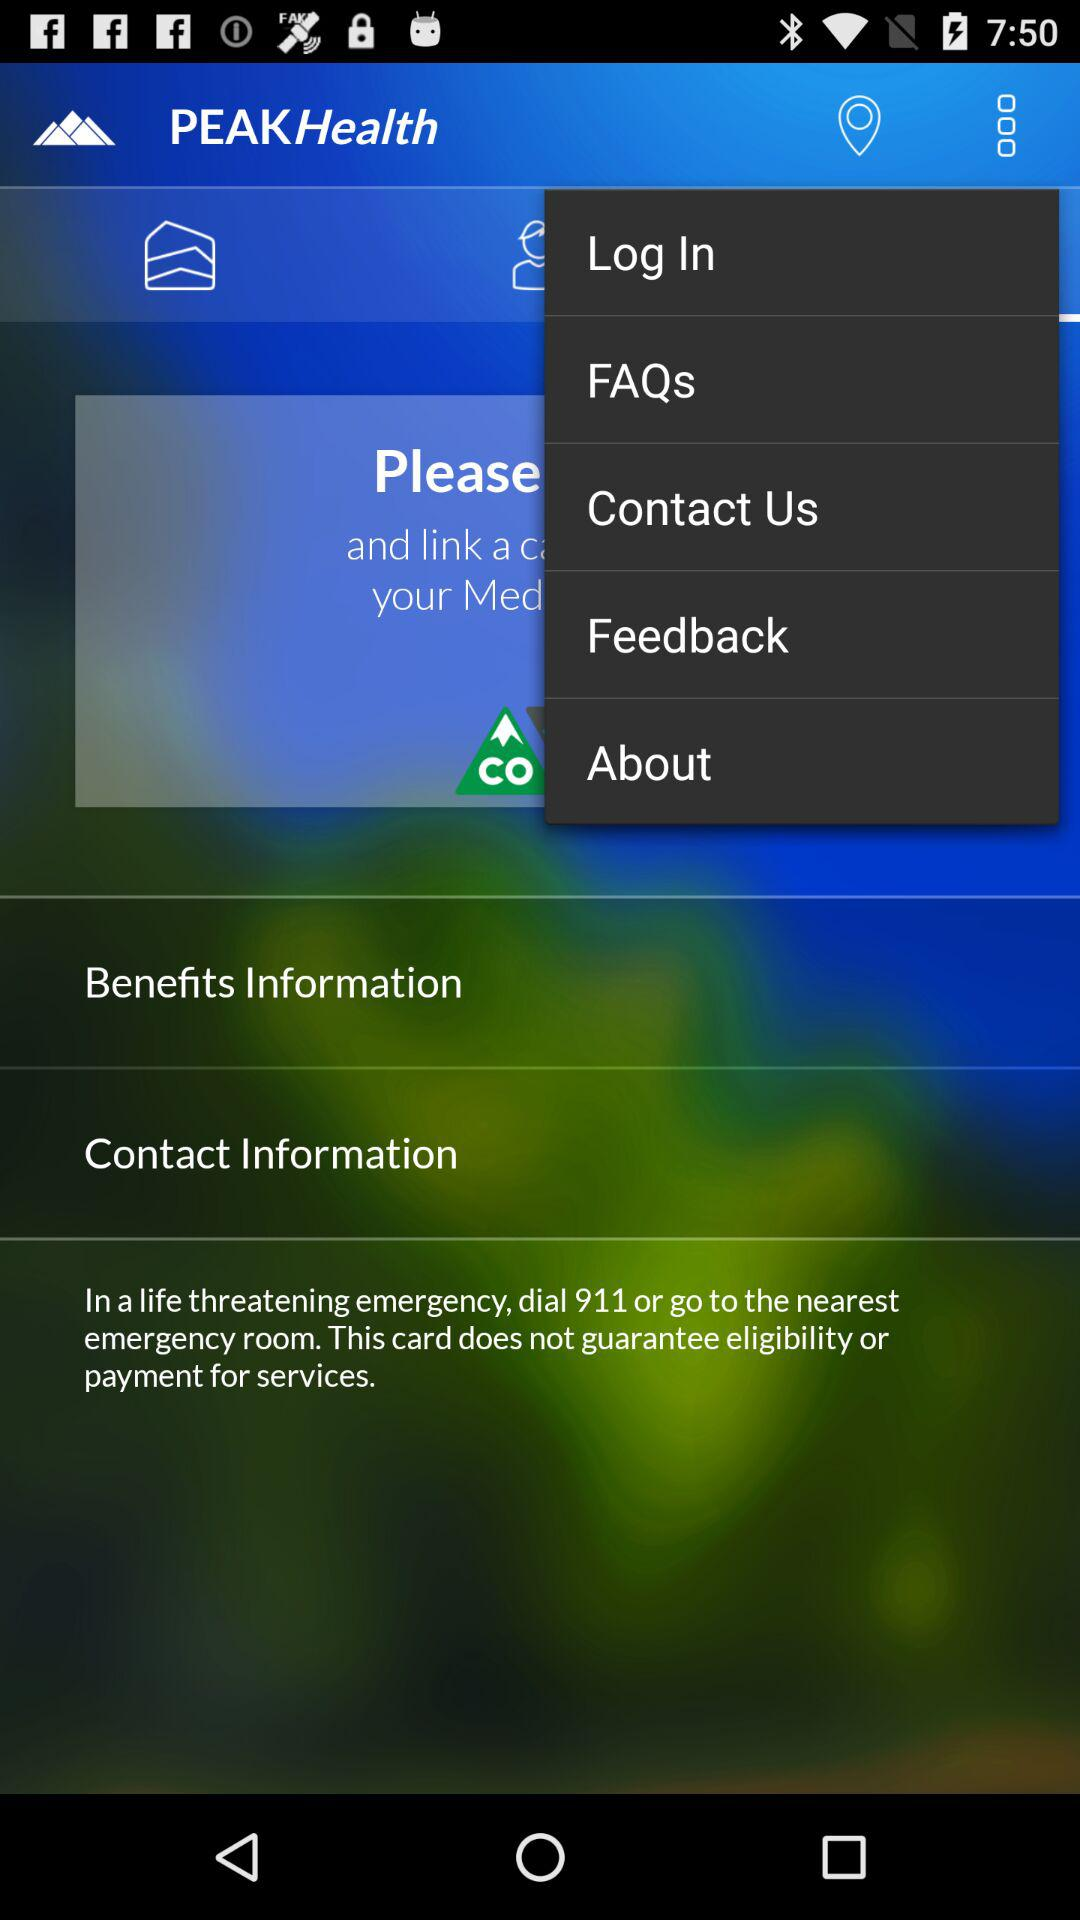With what name can the user log in?
When the provided information is insufficient, respond with <no answer>. <no answer> 